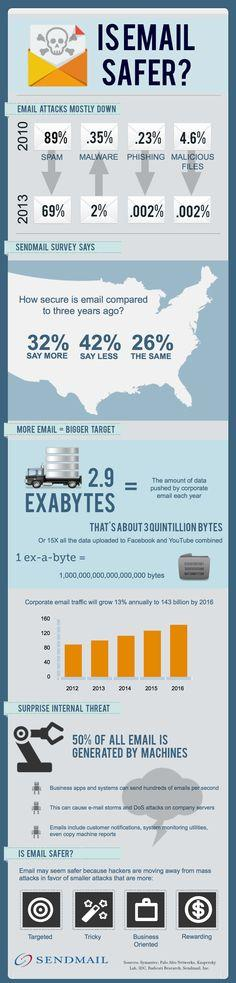Point out several critical features in this image. In 2013, there was a 20% decrease in the amount of spam mail compared to 2010. The number of malware attacks from 2010 to 2013 increased. According to the survey, 26% of respondents feel that email security is the same compared to three years ago. 